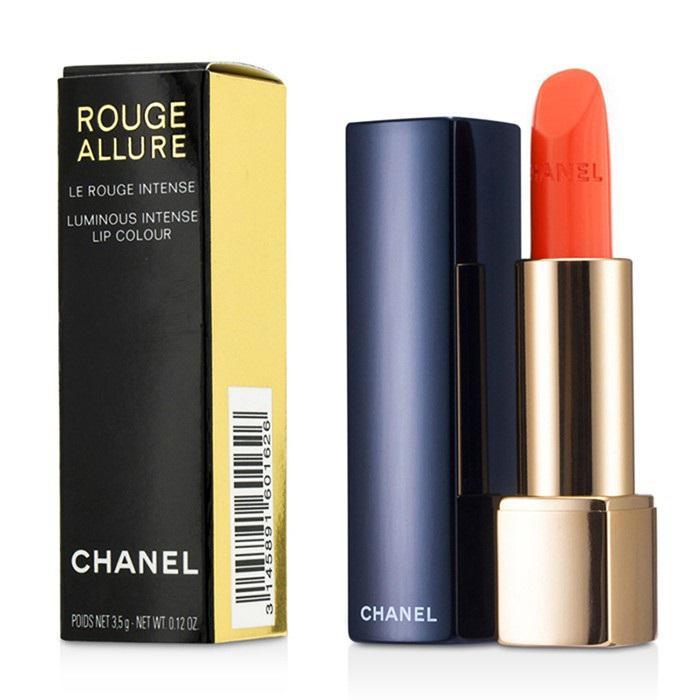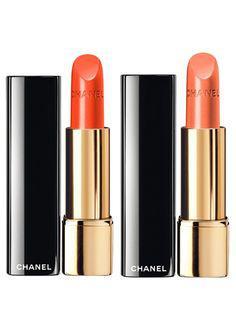The first image is the image on the left, the second image is the image on the right. For the images shown, is this caption "An image features one orange lipstick standing next to its upright lid." true? Answer yes or no. Yes. The first image is the image on the left, the second image is the image on the right. Given the left and right images, does the statement "One lipstick is extended to show its color with its cap sitting beside it, while a second lipstick is closed, but with a visible color." hold true? Answer yes or no. No. 